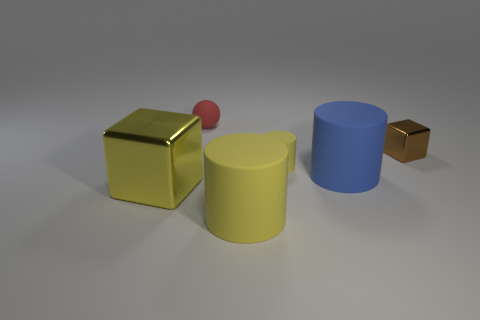Are there any tiny cylinders of the same color as the large cube?
Keep it short and to the point. Yes. Do the rubber sphere and the tiny metal object have the same color?
Offer a very short reply. No. What shape is the rubber object that is the same color as the small cylinder?
Your answer should be very brief. Cylinder. Is the number of blue objects less than the number of large yellow things?
Your answer should be compact. Yes. What number of things are either large brown matte cylinders or large yellow cubes?
Provide a succinct answer. 1. Does the small brown thing have the same shape as the blue rubber object?
Your response must be concise. No. Is the size of the yellow matte cylinder that is behind the big yellow metal block the same as the cube to the right of the big yellow rubber cylinder?
Ensure brevity in your answer.  Yes. There is a large thing that is in front of the large blue object and right of the yellow cube; what is it made of?
Keep it short and to the point. Rubber. Is there anything else that has the same color as the small metallic thing?
Offer a very short reply. No. Is the number of red spheres on the right side of the red object less than the number of large purple spheres?
Keep it short and to the point. No. 